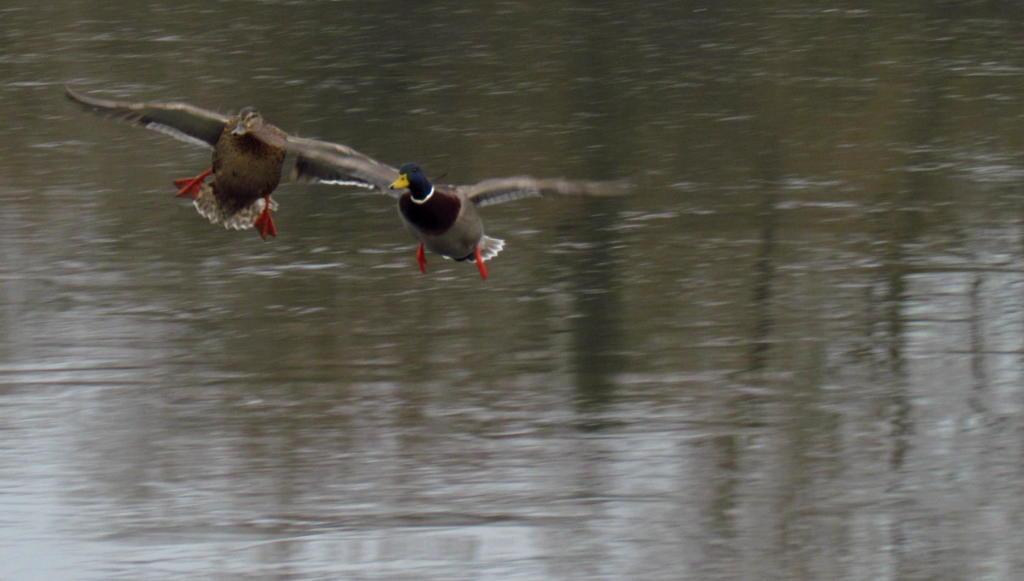Can you describe this image briefly? There are two birds flying on the water,the first bird has a blue neck and a yellow beak. 